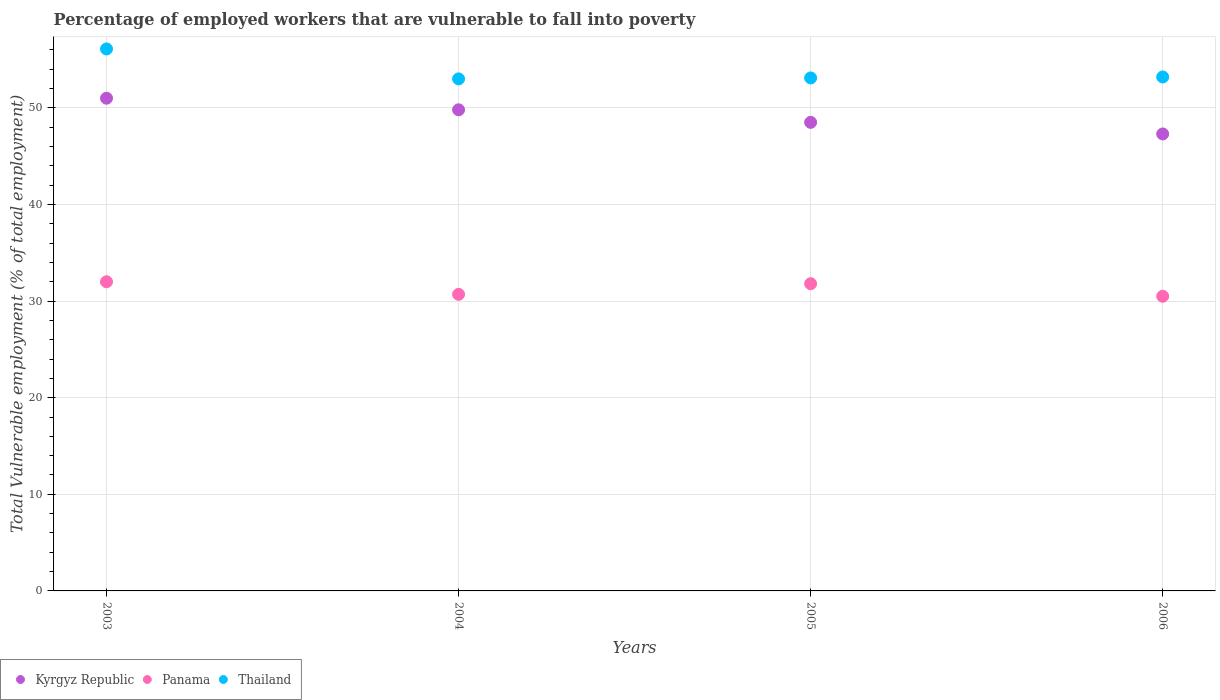How many different coloured dotlines are there?
Offer a very short reply. 3. What is the percentage of employed workers who are vulnerable to fall into poverty in Panama in 2005?
Your answer should be very brief. 31.8. Across all years, what is the maximum percentage of employed workers who are vulnerable to fall into poverty in Thailand?
Offer a terse response. 56.1. Across all years, what is the minimum percentage of employed workers who are vulnerable to fall into poverty in Kyrgyz Republic?
Your response must be concise. 47.3. What is the total percentage of employed workers who are vulnerable to fall into poverty in Thailand in the graph?
Ensure brevity in your answer.  215.4. What is the difference between the percentage of employed workers who are vulnerable to fall into poverty in Thailand in 2005 and that in 2006?
Offer a very short reply. -0.1. What is the difference between the percentage of employed workers who are vulnerable to fall into poverty in Kyrgyz Republic in 2004 and the percentage of employed workers who are vulnerable to fall into poverty in Thailand in 2005?
Give a very brief answer. -3.3. What is the average percentage of employed workers who are vulnerable to fall into poverty in Kyrgyz Republic per year?
Ensure brevity in your answer.  49.15. In the year 2004, what is the difference between the percentage of employed workers who are vulnerable to fall into poverty in Kyrgyz Republic and percentage of employed workers who are vulnerable to fall into poverty in Thailand?
Provide a succinct answer. -3.2. What is the ratio of the percentage of employed workers who are vulnerable to fall into poverty in Thailand in 2003 to that in 2005?
Give a very brief answer. 1.06. Is the percentage of employed workers who are vulnerable to fall into poverty in Thailand in 2005 less than that in 2006?
Offer a very short reply. Yes. Is the difference between the percentage of employed workers who are vulnerable to fall into poverty in Kyrgyz Republic in 2004 and 2005 greater than the difference between the percentage of employed workers who are vulnerable to fall into poverty in Thailand in 2004 and 2005?
Make the answer very short. Yes. What is the difference between the highest and the second highest percentage of employed workers who are vulnerable to fall into poverty in Thailand?
Your answer should be very brief. 2.9. What is the difference between the highest and the lowest percentage of employed workers who are vulnerable to fall into poverty in Kyrgyz Republic?
Provide a succinct answer. 3.7. In how many years, is the percentage of employed workers who are vulnerable to fall into poverty in Thailand greater than the average percentage of employed workers who are vulnerable to fall into poverty in Thailand taken over all years?
Keep it short and to the point. 1. Is the sum of the percentage of employed workers who are vulnerable to fall into poverty in Panama in 2003 and 2006 greater than the maximum percentage of employed workers who are vulnerable to fall into poverty in Kyrgyz Republic across all years?
Offer a very short reply. Yes. Is it the case that in every year, the sum of the percentage of employed workers who are vulnerable to fall into poverty in Thailand and percentage of employed workers who are vulnerable to fall into poverty in Kyrgyz Republic  is greater than the percentage of employed workers who are vulnerable to fall into poverty in Panama?
Offer a very short reply. Yes. Is the percentage of employed workers who are vulnerable to fall into poverty in Kyrgyz Republic strictly greater than the percentage of employed workers who are vulnerable to fall into poverty in Thailand over the years?
Keep it short and to the point. No. How many dotlines are there?
Offer a terse response. 3. How many years are there in the graph?
Your response must be concise. 4. How are the legend labels stacked?
Ensure brevity in your answer.  Horizontal. What is the title of the graph?
Offer a very short reply. Percentage of employed workers that are vulnerable to fall into poverty. What is the label or title of the Y-axis?
Your answer should be compact. Total Vulnerable employment (% of total employment). What is the Total Vulnerable employment (% of total employment) in Thailand in 2003?
Offer a very short reply. 56.1. What is the Total Vulnerable employment (% of total employment) in Kyrgyz Republic in 2004?
Your response must be concise. 49.8. What is the Total Vulnerable employment (% of total employment) in Panama in 2004?
Give a very brief answer. 30.7. What is the Total Vulnerable employment (% of total employment) of Kyrgyz Republic in 2005?
Provide a succinct answer. 48.5. What is the Total Vulnerable employment (% of total employment) of Panama in 2005?
Provide a succinct answer. 31.8. What is the Total Vulnerable employment (% of total employment) in Thailand in 2005?
Your answer should be compact. 53.1. What is the Total Vulnerable employment (% of total employment) in Kyrgyz Republic in 2006?
Give a very brief answer. 47.3. What is the Total Vulnerable employment (% of total employment) in Panama in 2006?
Ensure brevity in your answer.  30.5. What is the Total Vulnerable employment (% of total employment) in Thailand in 2006?
Give a very brief answer. 53.2. Across all years, what is the maximum Total Vulnerable employment (% of total employment) in Kyrgyz Republic?
Provide a short and direct response. 51. Across all years, what is the maximum Total Vulnerable employment (% of total employment) of Panama?
Ensure brevity in your answer.  32. Across all years, what is the maximum Total Vulnerable employment (% of total employment) in Thailand?
Your response must be concise. 56.1. Across all years, what is the minimum Total Vulnerable employment (% of total employment) in Kyrgyz Republic?
Your response must be concise. 47.3. Across all years, what is the minimum Total Vulnerable employment (% of total employment) of Panama?
Offer a terse response. 30.5. Across all years, what is the minimum Total Vulnerable employment (% of total employment) in Thailand?
Offer a terse response. 53. What is the total Total Vulnerable employment (% of total employment) of Kyrgyz Republic in the graph?
Give a very brief answer. 196.6. What is the total Total Vulnerable employment (% of total employment) of Panama in the graph?
Give a very brief answer. 125. What is the total Total Vulnerable employment (% of total employment) of Thailand in the graph?
Provide a short and direct response. 215.4. What is the difference between the Total Vulnerable employment (% of total employment) of Panama in 2003 and that in 2004?
Your answer should be compact. 1.3. What is the difference between the Total Vulnerable employment (% of total employment) of Kyrgyz Republic in 2003 and that in 2005?
Make the answer very short. 2.5. What is the difference between the Total Vulnerable employment (% of total employment) of Panama in 2003 and that in 2005?
Your answer should be very brief. 0.2. What is the difference between the Total Vulnerable employment (% of total employment) of Thailand in 2003 and that in 2005?
Make the answer very short. 3. What is the difference between the Total Vulnerable employment (% of total employment) in Thailand in 2003 and that in 2006?
Your response must be concise. 2.9. What is the difference between the Total Vulnerable employment (% of total employment) of Panama in 2004 and that in 2005?
Provide a short and direct response. -1.1. What is the difference between the Total Vulnerable employment (% of total employment) in Thailand in 2004 and that in 2005?
Provide a succinct answer. -0.1. What is the difference between the Total Vulnerable employment (% of total employment) of Kyrgyz Republic in 2004 and that in 2006?
Offer a very short reply. 2.5. What is the difference between the Total Vulnerable employment (% of total employment) of Thailand in 2004 and that in 2006?
Give a very brief answer. -0.2. What is the difference between the Total Vulnerable employment (% of total employment) of Kyrgyz Republic in 2005 and that in 2006?
Offer a very short reply. 1.2. What is the difference between the Total Vulnerable employment (% of total employment) in Panama in 2005 and that in 2006?
Keep it short and to the point. 1.3. What is the difference between the Total Vulnerable employment (% of total employment) of Kyrgyz Republic in 2003 and the Total Vulnerable employment (% of total employment) of Panama in 2004?
Ensure brevity in your answer.  20.3. What is the difference between the Total Vulnerable employment (% of total employment) of Kyrgyz Republic in 2003 and the Total Vulnerable employment (% of total employment) of Panama in 2005?
Your answer should be compact. 19.2. What is the difference between the Total Vulnerable employment (% of total employment) of Panama in 2003 and the Total Vulnerable employment (% of total employment) of Thailand in 2005?
Give a very brief answer. -21.1. What is the difference between the Total Vulnerable employment (% of total employment) in Panama in 2003 and the Total Vulnerable employment (% of total employment) in Thailand in 2006?
Your response must be concise. -21.2. What is the difference between the Total Vulnerable employment (% of total employment) in Kyrgyz Republic in 2004 and the Total Vulnerable employment (% of total employment) in Panama in 2005?
Offer a very short reply. 18. What is the difference between the Total Vulnerable employment (% of total employment) in Panama in 2004 and the Total Vulnerable employment (% of total employment) in Thailand in 2005?
Provide a short and direct response. -22.4. What is the difference between the Total Vulnerable employment (% of total employment) of Kyrgyz Republic in 2004 and the Total Vulnerable employment (% of total employment) of Panama in 2006?
Ensure brevity in your answer.  19.3. What is the difference between the Total Vulnerable employment (% of total employment) in Kyrgyz Republic in 2004 and the Total Vulnerable employment (% of total employment) in Thailand in 2006?
Your answer should be very brief. -3.4. What is the difference between the Total Vulnerable employment (% of total employment) of Panama in 2004 and the Total Vulnerable employment (% of total employment) of Thailand in 2006?
Keep it short and to the point. -22.5. What is the difference between the Total Vulnerable employment (% of total employment) in Panama in 2005 and the Total Vulnerable employment (% of total employment) in Thailand in 2006?
Offer a very short reply. -21.4. What is the average Total Vulnerable employment (% of total employment) in Kyrgyz Republic per year?
Provide a short and direct response. 49.15. What is the average Total Vulnerable employment (% of total employment) of Panama per year?
Your answer should be very brief. 31.25. What is the average Total Vulnerable employment (% of total employment) in Thailand per year?
Your answer should be compact. 53.85. In the year 2003, what is the difference between the Total Vulnerable employment (% of total employment) of Kyrgyz Republic and Total Vulnerable employment (% of total employment) of Thailand?
Provide a succinct answer. -5.1. In the year 2003, what is the difference between the Total Vulnerable employment (% of total employment) of Panama and Total Vulnerable employment (% of total employment) of Thailand?
Provide a short and direct response. -24.1. In the year 2004, what is the difference between the Total Vulnerable employment (% of total employment) of Panama and Total Vulnerable employment (% of total employment) of Thailand?
Keep it short and to the point. -22.3. In the year 2005, what is the difference between the Total Vulnerable employment (% of total employment) of Kyrgyz Republic and Total Vulnerable employment (% of total employment) of Panama?
Your answer should be compact. 16.7. In the year 2005, what is the difference between the Total Vulnerable employment (% of total employment) of Kyrgyz Republic and Total Vulnerable employment (% of total employment) of Thailand?
Provide a short and direct response. -4.6. In the year 2005, what is the difference between the Total Vulnerable employment (% of total employment) in Panama and Total Vulnerable employment (% of total employment) in Thailand?
Keep it short and to the point. -21.3. In the year 2006, what is the difference between the Total Vulnerable employment (% of total employment) in Kyrgyz Republic and Total Vulnerable employment (% of total employment) in Thailand?
Provide a succinct answer. -5.9. In the year 2006, what is the difference between the Total Vulnerable employment (% of total employment) of Panama and Total Vulnerable employment (% of total employment) of Thailand?
Provide a succinct answer. -22.7. What is the ratio of the Total Vulnerable employment (% of total employment) of Kyrgyz Republic in 2003 to that in 2004?
Your answer should be compact. 1.02. What is the ratio of the Total Vulnerable employment (% of total employment) of Panama in 2003 to that in 2004?
Provide a succinct answer. 1.04. What is the ratio of the Total Vulnerable employment (% of total employment) in Thailand in 2003 to that in 2004?
Ensure brevity in your answer.  1.06. What is the ratio of the Total Vulnerable employment (% of total employment) of Kyrgyz Republic in 2003 to that in 2005?
Make the answer very short. 1.05. What is the ratio of the Total Vulnerable employment (% of total employment) of Thailand in 2003 to that in 2005?
Provide a short and direct response. 1.06. What is the ratio of the Total Vulnerable employment (% of total employment) of Kyrgyz Republic in 2003 to that in 2006?
Offer a terse response. 1.08. What is the ratio of the Total Vulnerable employment (% of total employment) of Panama in 2003 to that in 2006?
Keep it short and to the point. 1.05. What is the ratio of the Total Vulnerable employment (% of total employment) in Thailand in 2003 to that in 2006?
Provide a succinct answer. 1.05. What is the ratio of the Total Vulnerable employment (% of total employment) of Kyrgyz Republic in 2004 to that in 2005?
Your answer should be very brief. 1.03. What is the ratio of the Total Vulnerable employment (% of total employment) of Panama in 2004 to that in 2005?
Your response must be concise. 0.97. What is the ratio of the Total Vulnerable employment (% of total employment) of Thailand in 2004 to that in 2005?
Give a very brief answer. 1. What is the ratio of the Total Vulnerable employment (% of total employment) in Kyrgyz Republic in 2004 to that in 2006?
Provide a succinct answer. 1.05. What is the ratio of the Total Vulnerable employment (% of total employment) in Panama in 2004 to that in 2006?
Provide a short and direct response. 1.01. What is the ratio of the Total Vulnerable employment (% of total employment) in Thailand in 2004 to that in 2006?
Your response must be concise. 1. What is the ratio of the Total Vulnerable employment (% of total employment) in Kyrgyz Republic in 2005 to that in 2006?
Give a very brief answer. 1.03. What is the ratio of the Total Vulnerable employment (% of total employment) in Panama in 2005 to that in 2006?
Give a very brief answer. 1.04. What is the ratio of the Total Vulnerable employment (% of total employment) in Thailand in 2005 to that in 2006?
Provide a succinct answer. 1. What is the difference between the highest and the lowest Total Vulnerable employment (% of total employment) of Kyrgyz Republic?
Ensure brevity in your answer.  3.7. What is the difference between the highest and the lowest Total Vulnerable employment (% of total employment) in Panama?
Offer a very short reply. 1.5. 